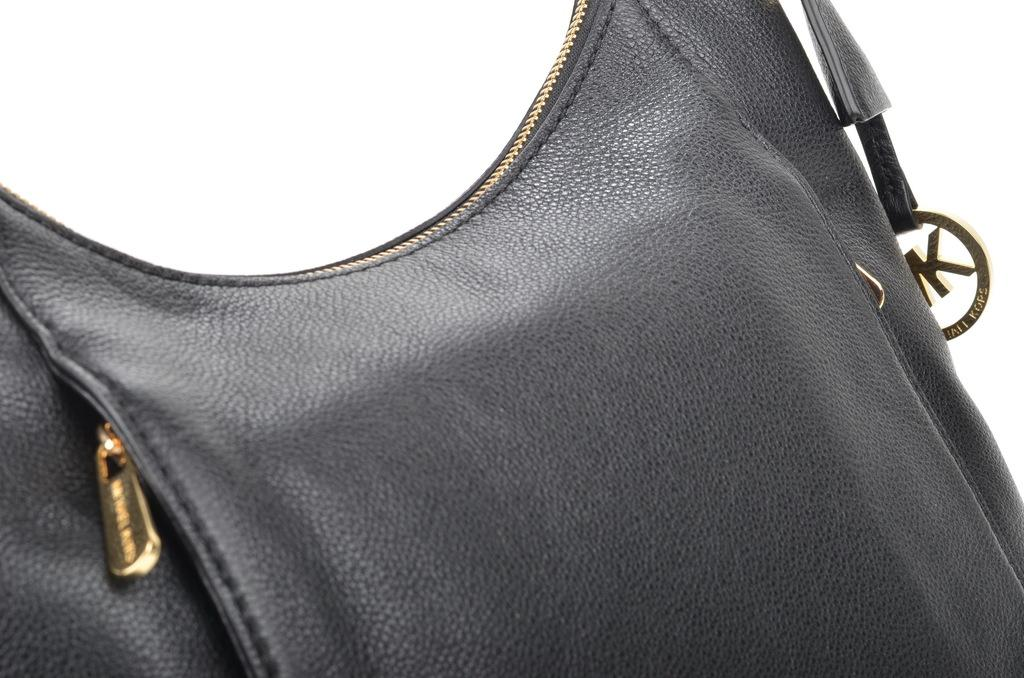What object can be seen in the image? There is a bag in the image. What is the color of the bag? The bag is black in color. What material is the bag made of? The bag is made of leather. How many glass bottles are inside the black leather bag in the image? There is no mention of glass bottles or any other items inside the bag in the provided facts, so we cannot determine their presence or quantity. 